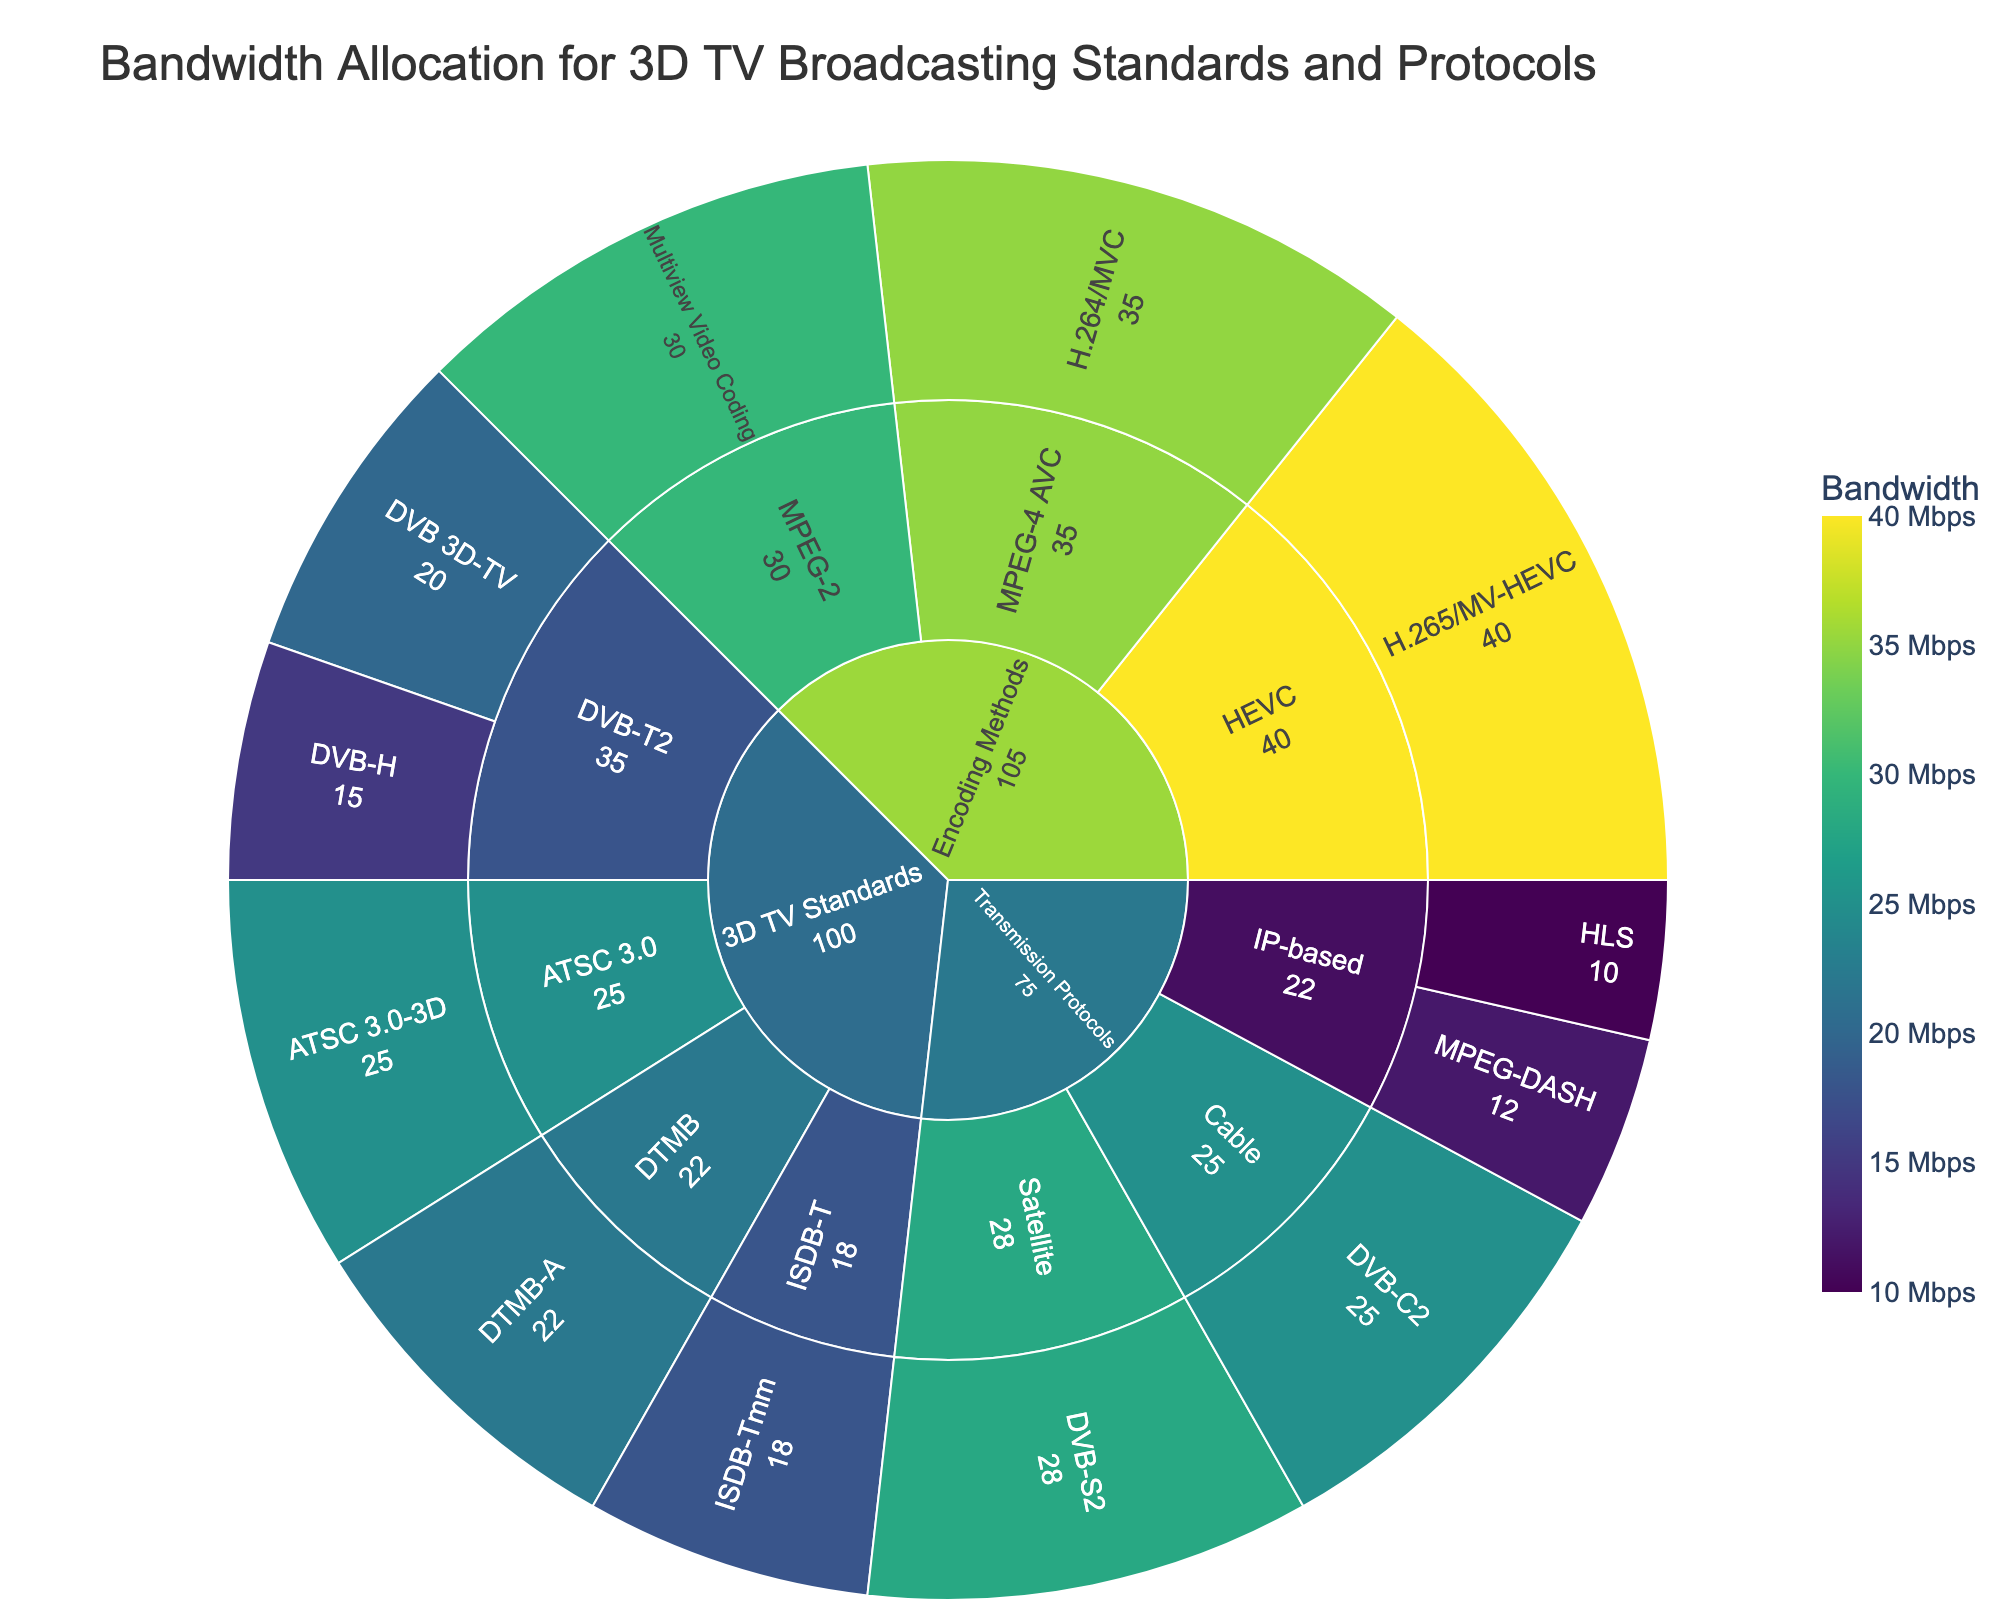What is the title of the Sunburst Plot? The title is generally displayed at the top of the figure and is a textual representation of what the plot depicts.
Answer: Bandwidth Allocation for 3D TV Broadcasting Standards and Protocols Which protocol has the highest bandwidth allocation in the Encoding Methods category? By looking at the plot, locate the Encoding Methods section and identify the protocol with the largest bandwidth slice.
Answer: H.265/MV-HEVC What is the total bandwidth allocated to 3D TV Standards? Sum the bandwidths of all protocols listed under 3D TV Standards. The segments combine to make up the composite value.
Answer: 100 Mbps (20+15+25+18+22) Compare the bandwidth allocation between DVB-S2 and DVB-C2 in the Transmission Protocols category. Which one is larger, and by how much? Look at the segments under Transmission Protocols, compare the bandwidth allocations, and calculate the difference. DVB-S2 is 28 Mbps, and DVB-C2 is 25 Mbps, so DVB-S2 has 3 Mbps more bandwidth.
Answer: DVB-S2; 3 Mbps What is the smallest bandwidth allocation among all the protocols, and which protocol does it belong to? Identify the smallest segment across all categories and note the bandwidth and the protocol. The smallest segment belongs to HLS in the Transmission Protocols, with 10 Mbps.
Answer: HLS; 10 Mbps What is the average bandwidth allocation for the protocols under IP-based in Transmission Protocols? Sum the bandwidths of the IP-based protocols (MPEG-DASH and HLS) and divide by the number of protocols. (12+10)/2 = 11 Mbps.
Answer: 11 Mbps Which category has the highest total bandwidth allocation, and what is its value? Sum the bandwidths of all protocols within each category and compare the totals. Encoding Methods has the highest total (30+35+40) = 105 Mbps.
Answer: Encoding Methods; 105 Mbps How does the bandwidth of ATSC 3.0-3D compare to that of ISDB-Tmm? Locate the respective segments and compare their bandwidth values. ATSC 3.0-3D has 25 Mbps, and ISDB-Tmm has 18 Mbps, so ATSC 3.0-3D has 7 Mbps more bandwidth.
Answer: ATSC 3.0-3D has 7 Mbps more What percentage of the total bandwidth allocation is taken up by Multiview Video Coding under Encoding Methods? Sum the total bandwidth of all protocols and calculate the percentage taken up by Multiview Video Coding. The total is 280 Mbps, and Multiview Video Coding is 30 Mbps. (30/280) * 100 ≈ 10.71%.
Answer: Approximately 10.71% Which protocol under 3D TV Standards has the smallest bandwidth allocation, and what is its value? Identify the protocol with the smallest segment under 3D TV Standards and note its bandwidth. DVB-H has the smallest value with 15 Mbps.
Answer: DVB-H; 15 Mbps 